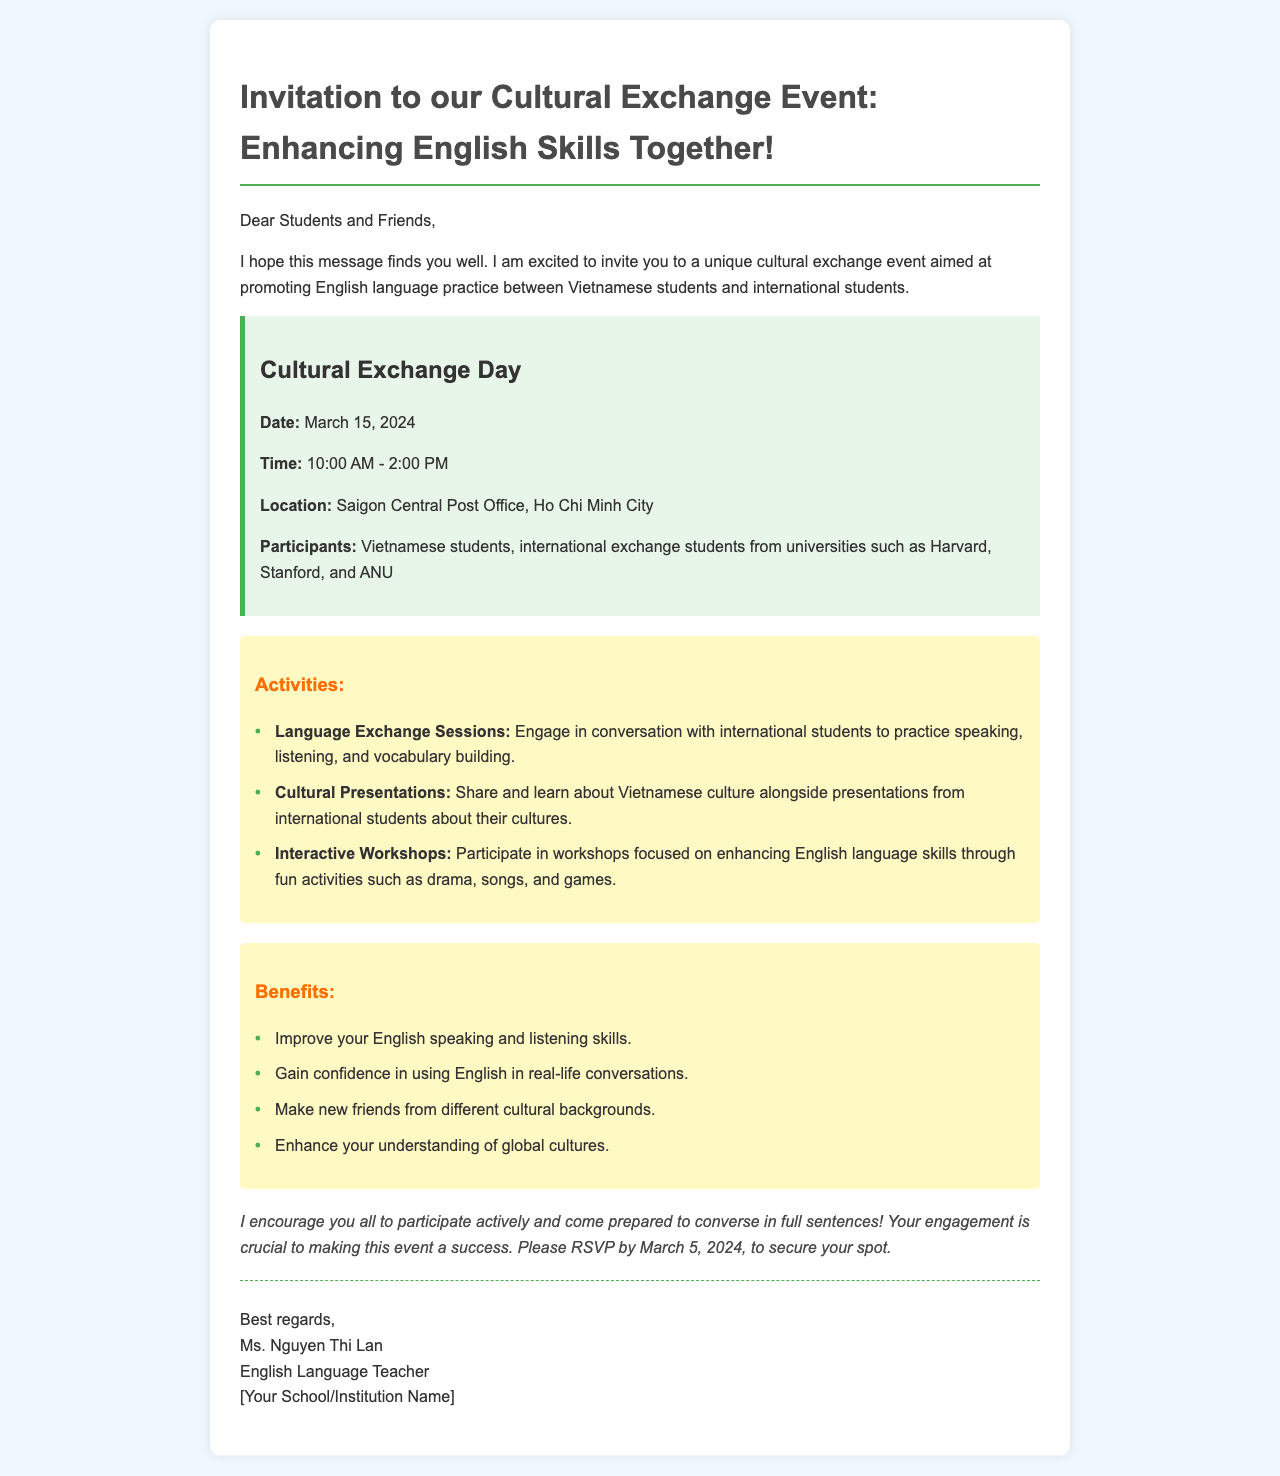What is the title of the event? The title of the event is mentioned at the top of the document and emphasizes its purpose of enhancing English skills.
Answer: Invitation to our Cultural Exchange Event: Enhancing English Skills Together! What is the date of the event? The date of the event is a specific detail outlined in the event details section of the document.
Answer: March 15, 2024 What is the location of the event? The location is specified in the event details section, indicating where the cultural exchange will take place.
Answer: Saigon Central Post Office, Ho Chi Minh City Who are the participants? The document specifies the type of participants involved in the event, highlighting both Vietnamese and international students.
Answer: Vietnamese students, international exchange students What is one of the benefits of attending? The benefits section lists several advantages of attending the event. It highlights that attendees can improve their English speaking skills.
Answer: Improve your English speaking and listening skills What type of activities will be included? The activities section mentions various engagement opportunities that participants can expect during the event.
Answer: Language Exchange Sessions What is the RSVP deadline? The document specifies a deadline for confirming attendance, which is crucial for planning purposes.
Answer: March 5, 2024 Who is the sender of the invitation? The sender's information is provided at the end of the document, including their name and position.
Answer: Ms. Nguyen Thi Lan 